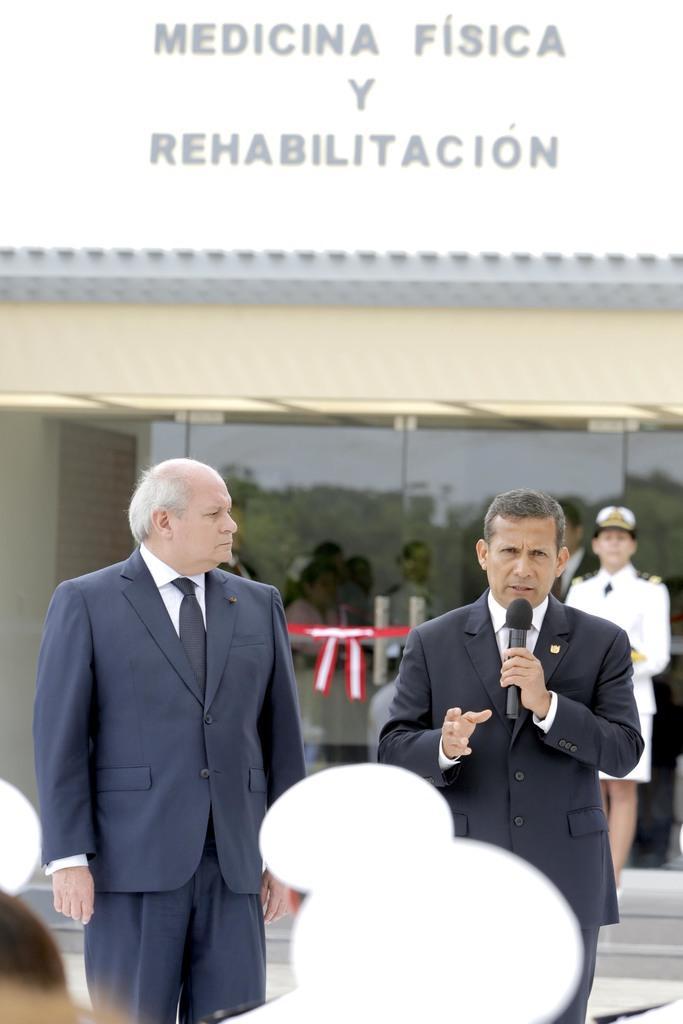Could you give a brief overview of what you see in this image? In this picture I can see 2 men in front who are wearing formal dress and I see that they're standing. The man on the right is holding a mic. In the background I can see a building and I see something is written on it and I see few people. 